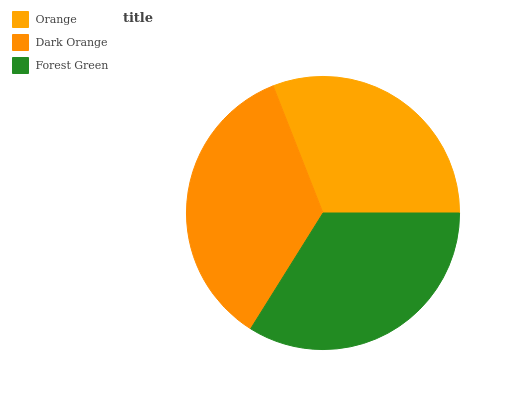Is Orange the minimum?
Answer yes or no. Yes. Is Dark Orange the maximum?
Answer yes or no. Yes. Is Forest Green the minimum?
Answer yes or no. No. Is Forest Green the maximum?
Answer yes or no. No. Is Dark Orange greater than Forest Green?
Answer yes or no. Yes. Is Forest Green less than Dark Orange?
Answer yes or no. Yes. Is Forest Green greater than Dark Orange?
Answer yes or no. No. Is Dark Orange less than Forest Green?
Answer yes or no. No. Is Forest Green the high median?
Answer yes or no. Yes. Is Forest Green the low median?
Answer yes or no. Yes. Is Dark Orange the high median?
Answer yes or no. No. Is Dark Orange the low median?
Answer yes or no. No. 